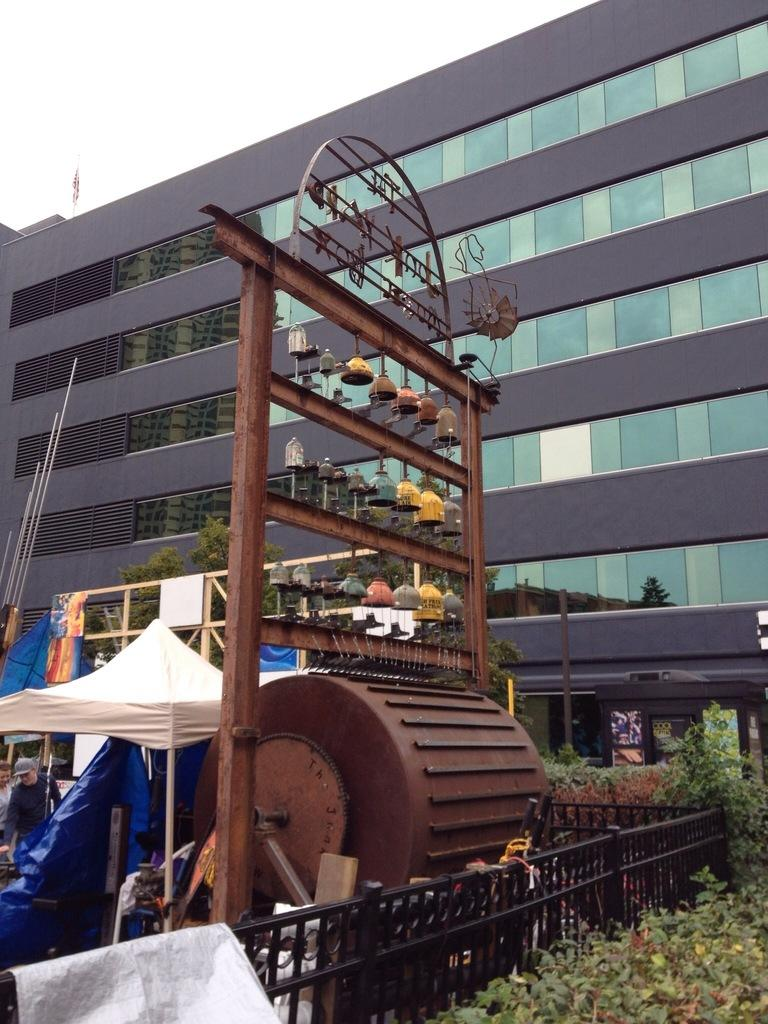What type of structure is visible in the image? There is a building in the image. What can be seen in the image besides the building? There are plants and a metal stand in the image. What is the purpose of the metal stand in the image? The metal stand is used to hold objects, as there are objects hanged on it. How many pies are visible on the metal stand in the image? There is no mention of pies in the image; the objects hanged on the metal stand are not specified. 